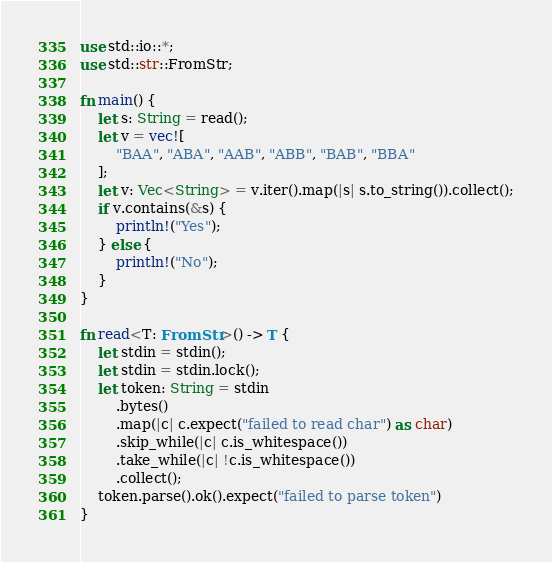<code> <loc_0><loc_0><loc_500><loc_500><_Rust_>use std::io::*;
use std::str::FromStr;

fn main() {
    let s: String = read();
    let v = vec![
        "BAA", "ABA", "AAB", "ABB", "BAB", "BBA"
    ];
    let v: Vec<String> = v.iter().map(|s| s.to_string()).collect();
    if v.contains(&s) {
        println!("Yes");
    } else {
        println!("No");
    }
}

fn read<T: FromStr>() -> T {
	let stdin = stdin();
	let stdin = stdin.lock();
	let token: String = stdin
		.bytes()
		.map(|c| c.expect("failed to read char") as char)
		.skip_while(|c| c.is_whitespace())
		.take_while(|c| !c.is_whitespace())
		.collect();
	token.parse().ok().expect("failed to parse token")
}

</code> 